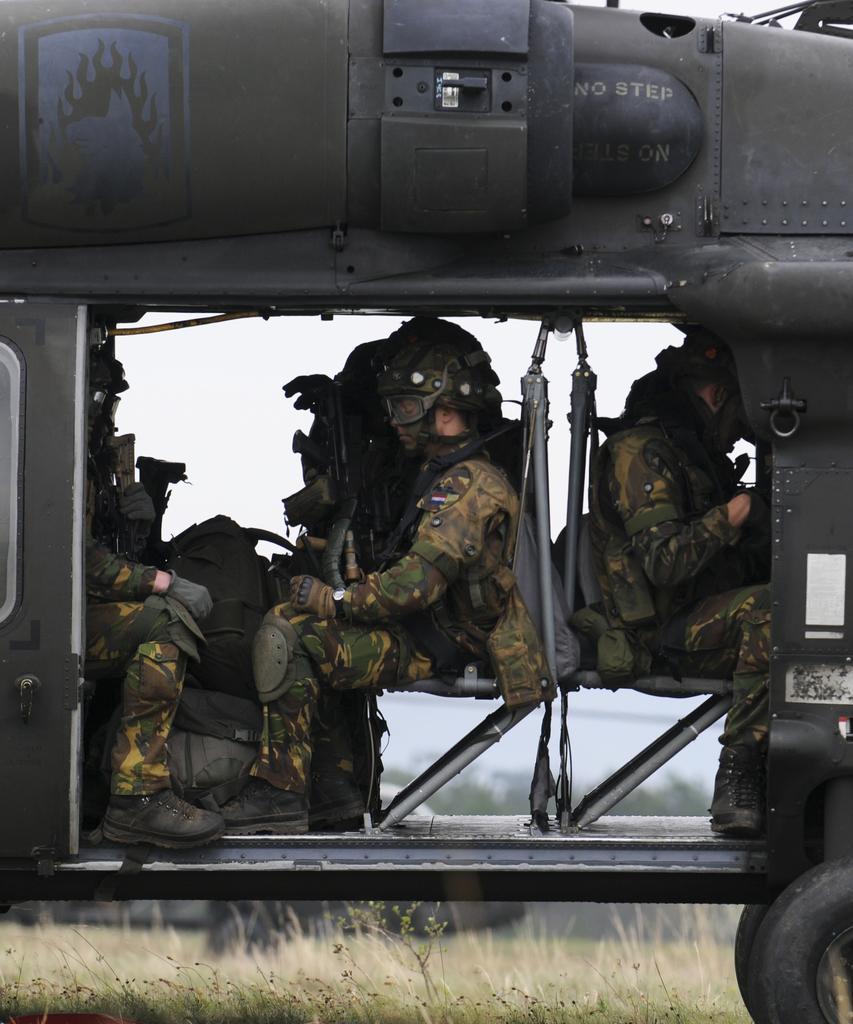How would you summarize this image in a sentence or two? In this image we can see persons sitting in the helicopter. At the bottom of the image we can see grass. In the background there are trees and sky. 